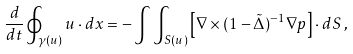<formula> <loc_0><loc_0><loc_500><loc_500>\frac { d } { d t } \oint _ { \gamma ( u ) } u \cdot d x = - \int \int _ { S ( u ) } \left [ \nabla \times ( 1 - \tilde { \Delta } ) ^ { - 1 } \nabla { p } \right ] \cdot d S \, ,</formula> 